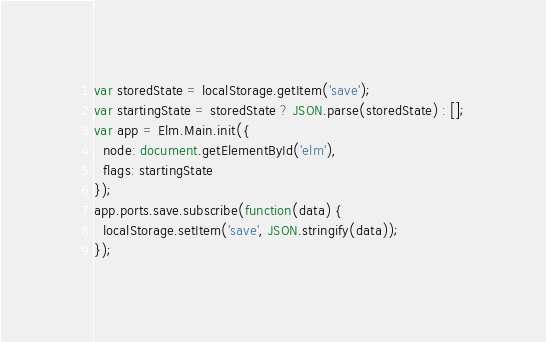Convert code to text. <code><loc_0><loc_0><loc_500><loc_500><_JavaScript_>var storedState = localStorage.getItem('save');
var startingState = storedState ? JSON.parse(storedState) : [];
var app = Elm.Main.init({
  node: document.getElementById('elm'),
  flags: startingState
});
app.ports.save.subscribe(function(data) {
  localStorage.setItem('save', JSON.stringify(data));
});
</code> 